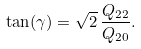Convert formula to latex. <formula><loc_0><loc_0><loc_500><loc_500>\tan ( \gamma ) = \sqrt { 2 } \, \frac { Q _ { 2 2 } } { Q _ { 2 0 } } .</formula> 